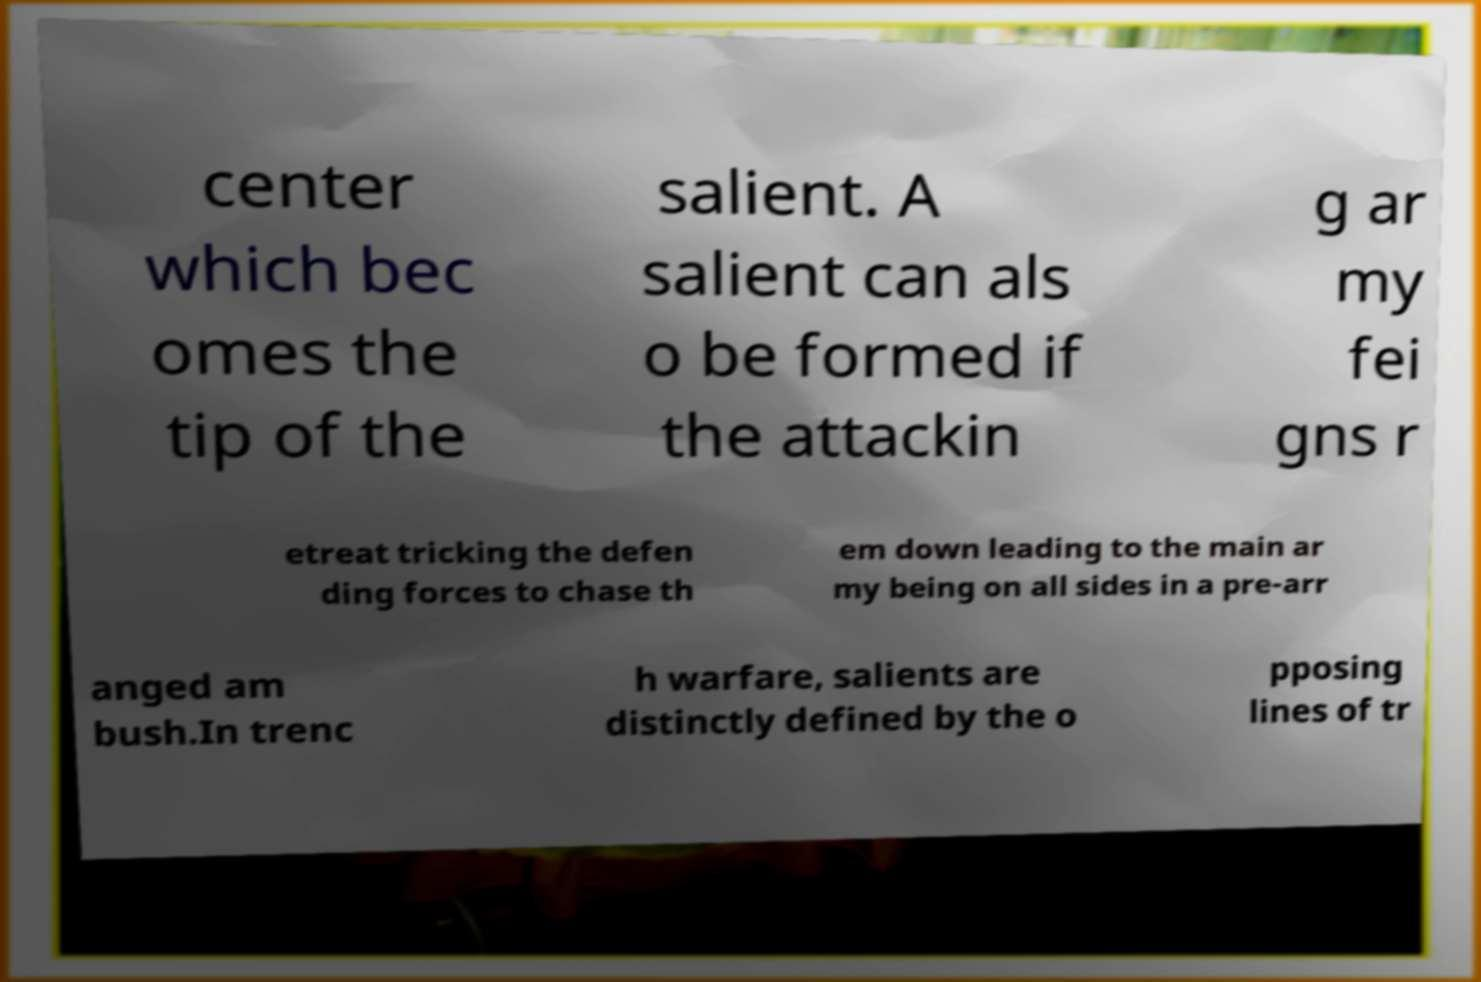There's text embedded in this image that I need extracted. Can you transcribe it verbatim? center which bec omes the tip of the salient. A salient can als o be formed if the attackin g ar my fei gns r etreat tricking the defen ding forces to chase th em down leading to the main ar my being on all sides in a pre-arr anged am bush.In trenc h warfare, salients are distinctly defined by the o pposing lines of tr 